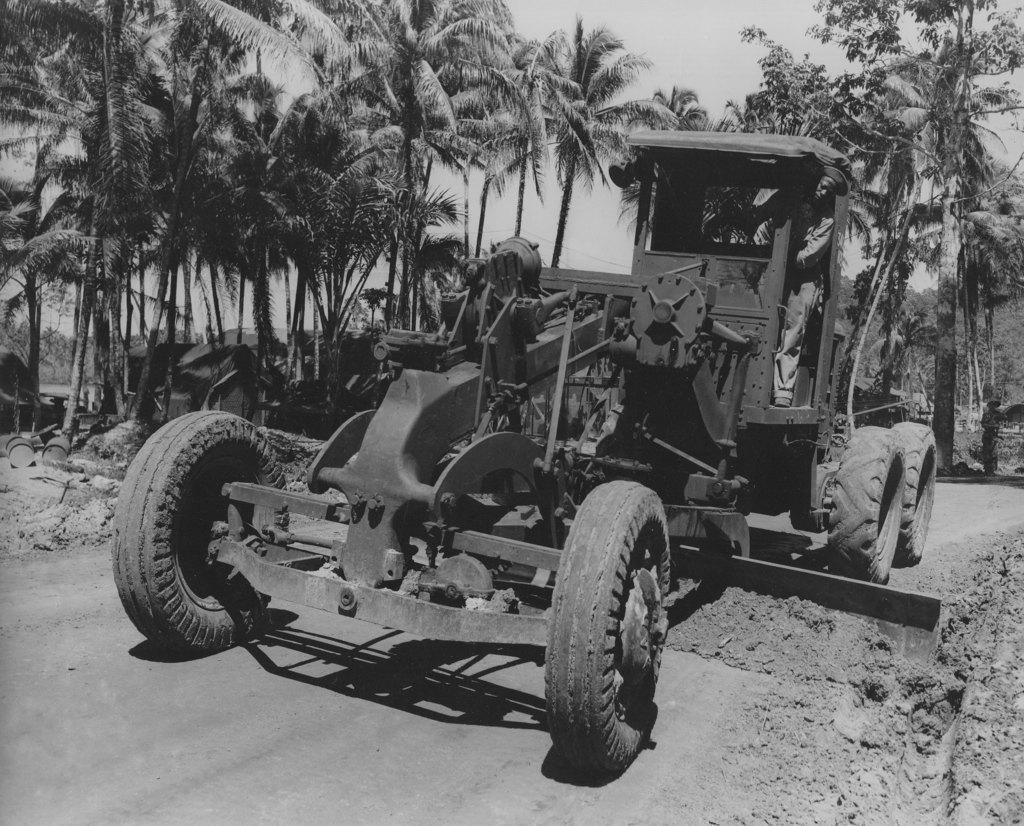Describe this image in one or two sentences. This is a black and white image. Here there is a vehicle on the road. In the background there are trees,drums,houses,other objects and sky. 